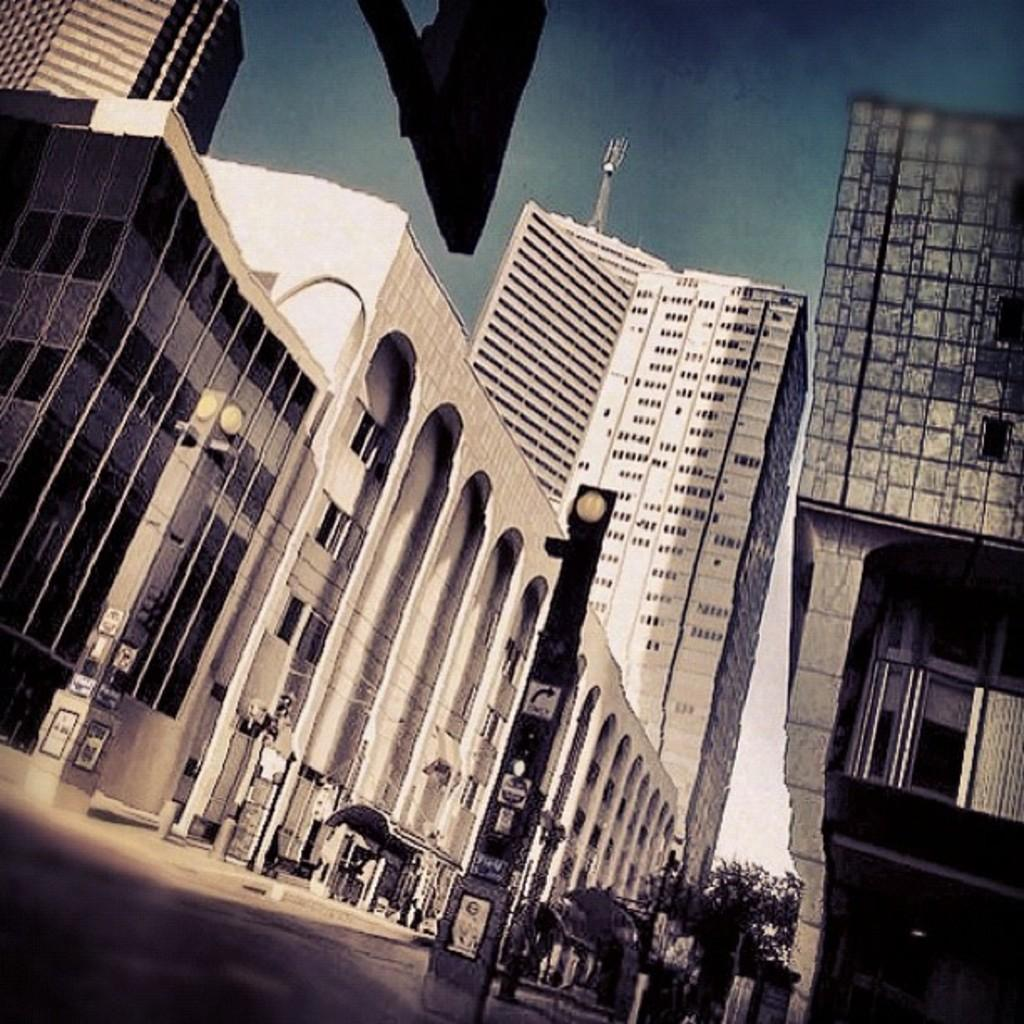What type of view is shown in the image? The image is an outside view. What can be seen at the bottom of the image? There are poles at the bottom of the image. What is present on the road in the image? There are trees on the road in the image. What is visible in the background of the image? There are many buildings in the background of the image. What is visible at the top of the image? The sky is visible at the top of the image. What type of blade is being used by the son in the image? There is no son or blade present in the image. What type of railway can be seen in the image? There is no railway present in the image. 